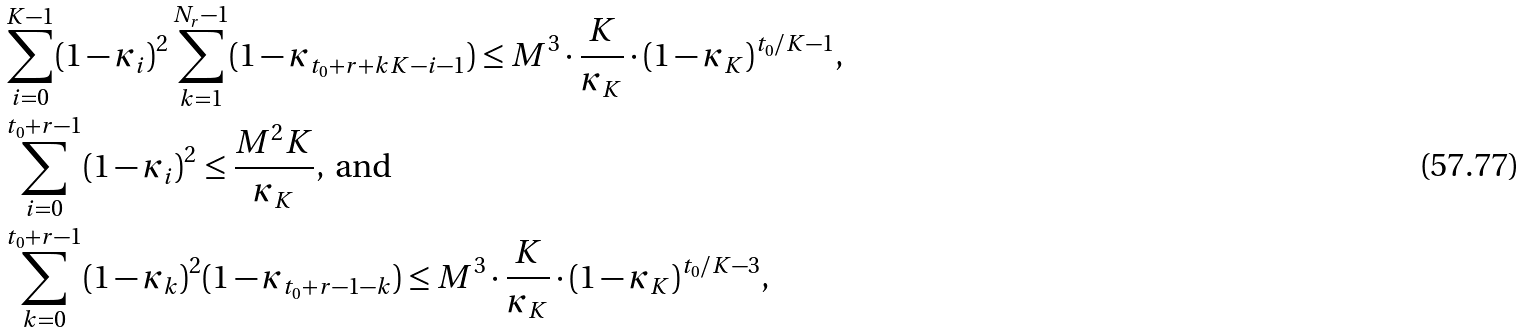<formula> <loc_0><loc_0><loc_500><loc_500>& \sum _ { i = 0 } ^ { K - 1 } ( 1 - \kappa _ { i } ) ^ { 2 } \sum _ { k = 1 } ^ { N _ { r } - 1 } ( 1 - \kappa _ { t _ { 0 } + r + k K - i - 1 } ) \leq M ^ { 3 } \cdot \frac { K } { \kappa _ { K } } \cdot ( 1 - \kappa _ { K } ) ^ { t _ { 0 } / K - 1 } , \\ & \sum _ { i = 0 } ^ { t _ { 0 } + r - 1 } ( 1 - \kappa _ { i } ) ^ { 2 } \leq \frac { M ^ { 2 } K } { \kappa _ { K } } , \text { and} \\ & \sum _ { k = 0 } ^ { t _ { 0 } + r - 1 } ( 1 - \kappa _ { k } ) ^ { 2 } ( 1 - \kappa _ { t _ { 0 } + r - 1 - k } ) \leq M ^ { 3 } \cdot \frac { K } { \kappa _ { K } } \cdot ( 1 - \kappa _ { K } ) ^ { t _ { 0 } / K - 3 } ,</formula> 